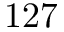<formula> <loc_0><loc_0><loc_500><loc_500>1 2 7</formula> 